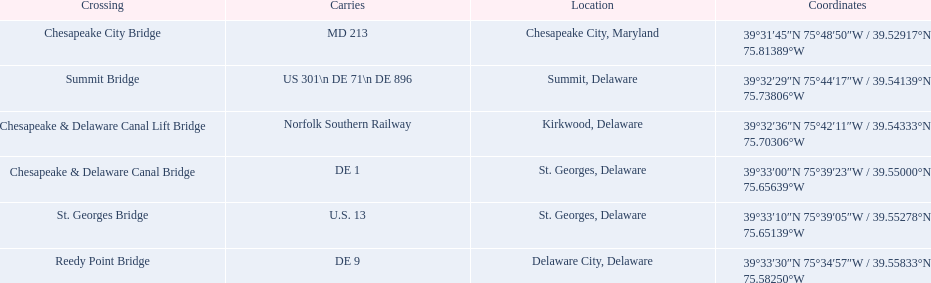Which intersection supports the highest number of routes (e.g., de 1)? Summit Bridge. I'm looking to parse the entire table for insights. Could you assist me with that? {'header': ['Crossing', 'Carries', 'Location', 'Coordinates'], 'rows': [['Chesapeake City Bridge', 'MD 213', 'Chesapeake City, Maryland', '39°31′45″N 75°48′50″W\ufeff / \ufeff39.52917°N 75.81389°W'], ['Summit Bridge', 'US 301\\n DE 71\\n DE 896', 'Summit, Delaware', '39°32′29″N 75°44′17″W\ufeff / \ufeff39.54139°N 75.73806°W'], ['Chesapeake & Delaware Canal Lift Bridge', 'Norfolk Southern Railway', 'Kirkwood, Delaware', '39°32′36″N 75°42′11″W\ufeff / \ufeff39.54333°N 75.70306°W'], ['Chesapeake & Delaware Canal Bridge', 'DE 1', 'St.\xa0Georges, Delaware', '39°33′00″N 75°39′23″W\ufeff / \ufeff39.55000°N 75.65639°W'], ['St.\xa0Georges Bridge', 'U.S.\xa013', 'St.\xa0Georges, Delaware', '39°33′10″N 75°39′05″W\ufeff / \ufeff39.55278°N 75.65139°W'], ['Reedy Point Bridge', 'DE\xa09', 'Delaware City, Delaware', '39°33′30″N 75°34′57″W\ufeff / \ufeff39.55833°N 75.58250°W']]} 